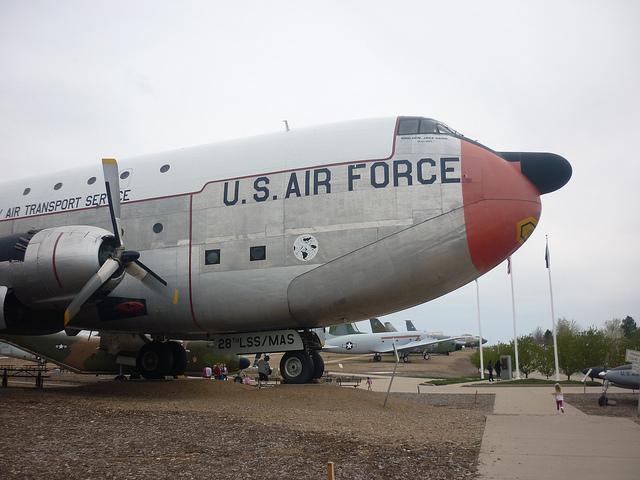How many circle windows are there on the plane?
Give a very brief answer. 6. How many airplanes are there?
Give a very brief answer. 2. How many skateboards can be seen?
Give a very brief answer. 0. 